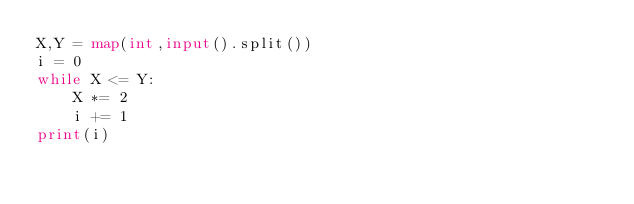Convert code to text. <code><loc_0><loc_0><loc_500><loc_500><_Python_>X,Y = map(int,input().split())
i = 0
while X <= Y:
    X *= 2
    i += 1
print(i)</code> 